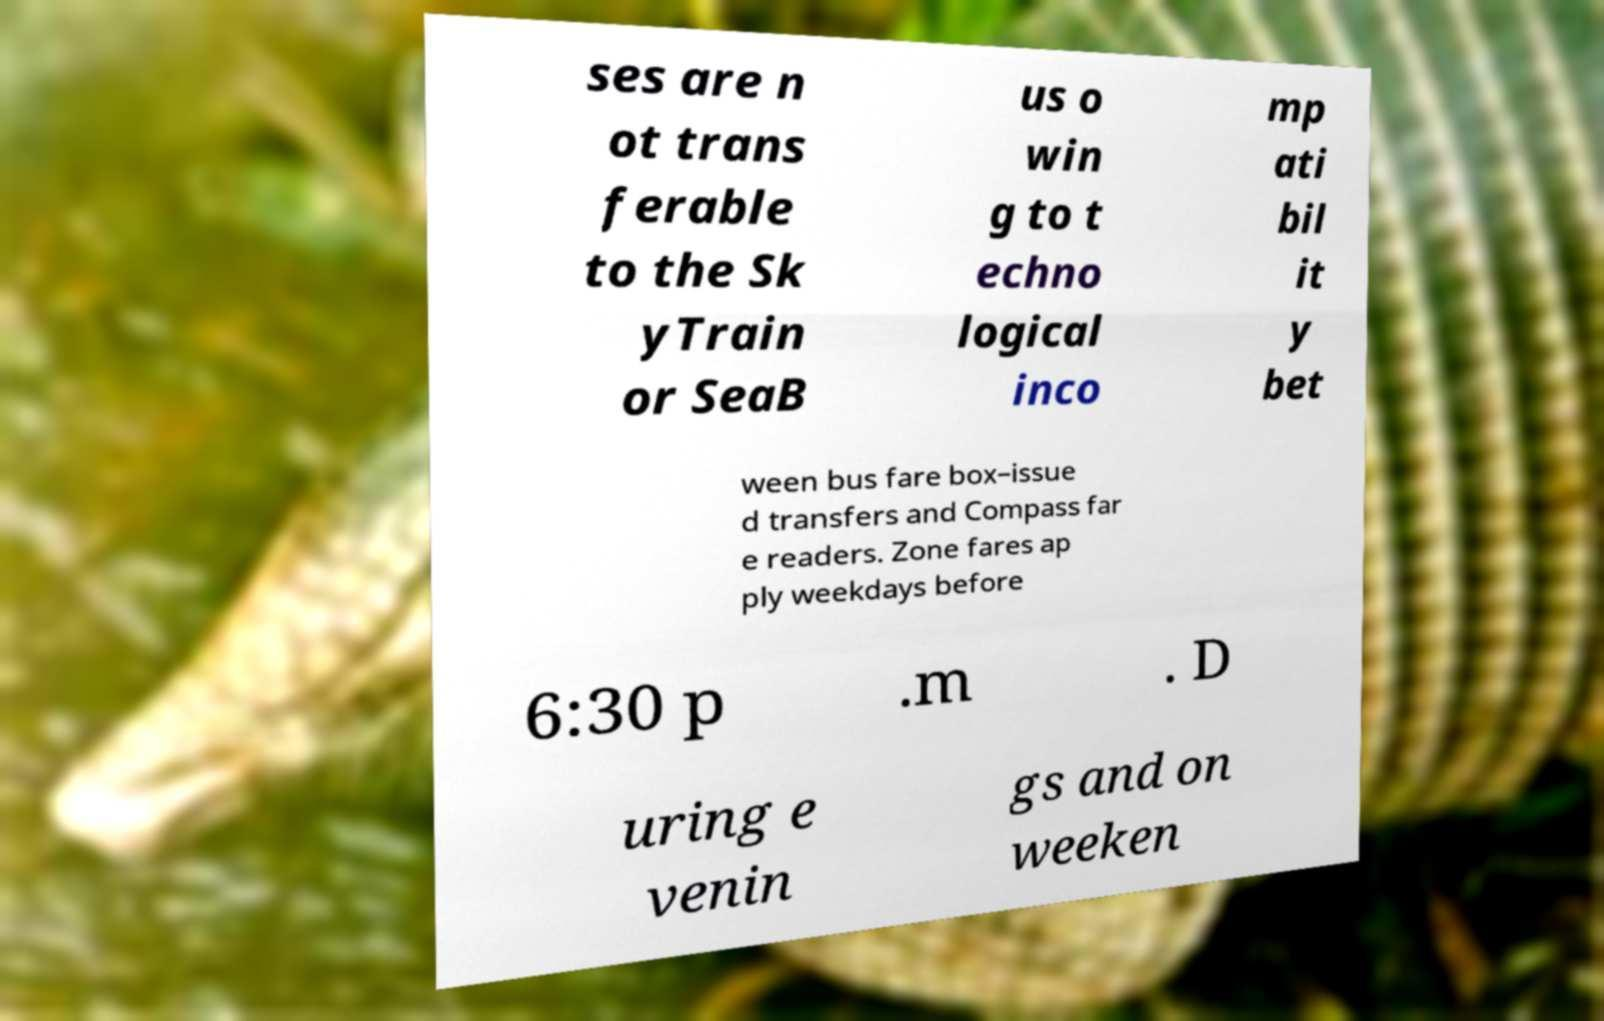Can you read and provide the text displayed in the image?This photo seems to have some interesting text. Can you extract and type it out for me? ses are n ot trans ferable to the Sk yTrain or SeaB us o win g to t echno logical inco mp ati bil it y bet ween bus fare box–issue d transfers and Compass far e readers. Zone fares ap ply weekdays before 6:30 p .m . D uring e venin gs and on weeken 